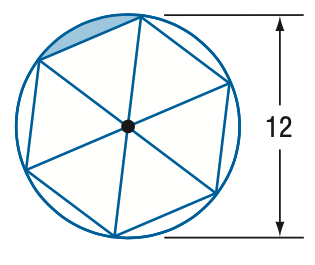Answer the mathemtical geometry problem and directly provide the correct option letter.
Question: Find the area of the shaded region. Assume the inscribed polygon is regular.
Choices: A: 3.3 B: 6.5 C: 12.3 D: 19.6 A 